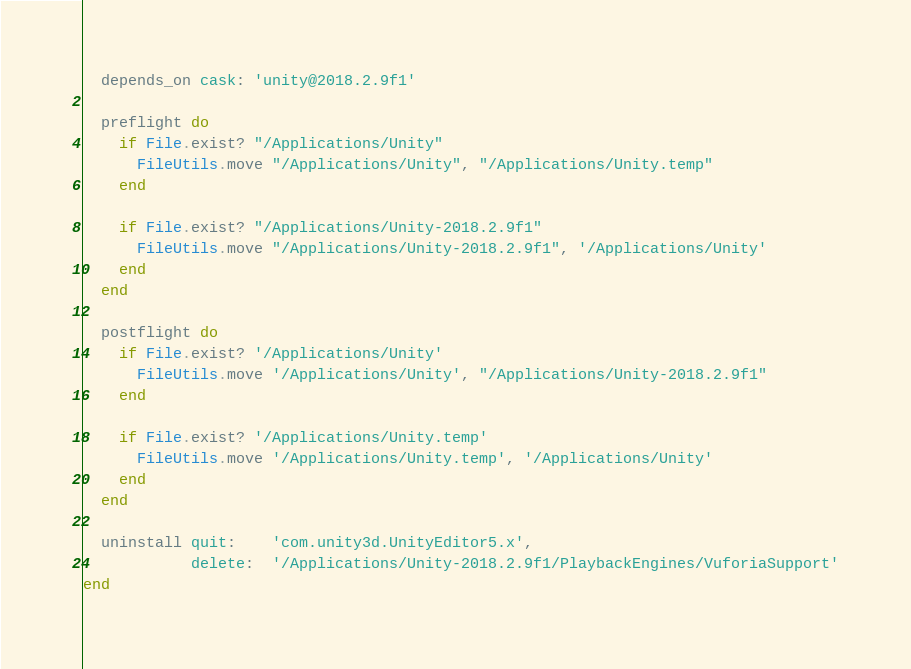Convert code to text. <code><loc_0><loc_0><loc_500><loc_500><_Ruby_>  depends_on cask: 'unity@2018.2.9f1'

  preflight do
    if File.exist? "/Applications/Unity"
      FileUtils.move "/Applications/Unity", "/Applications/Unity.temp"
    end

    if File.exist? "/Applications/Unity-2018.2.9f1"
      FileUtils.move "/Applications/Unity-2018.2.9f1", '/Applications/Unity'
    end
  end

  postflight do
    if File.exist? '/Applications/Unity'
      FileUtils.move '/Applications/Unity', "/Applications/Unity-2018.2.9f1"
    end

    if File.exist? '/Applications/Unity.temp'
      FileUtils.move '/Applications/Unity.temp', '/Applications/Unity'
    end
  end

  uninstall quit:    'com.unity3d.UnityEditor5.x',
            delete:  '/Applications/Unity-2018.2.9f1/PlaybackEngines/VuforiaSupport'
end
</code> 